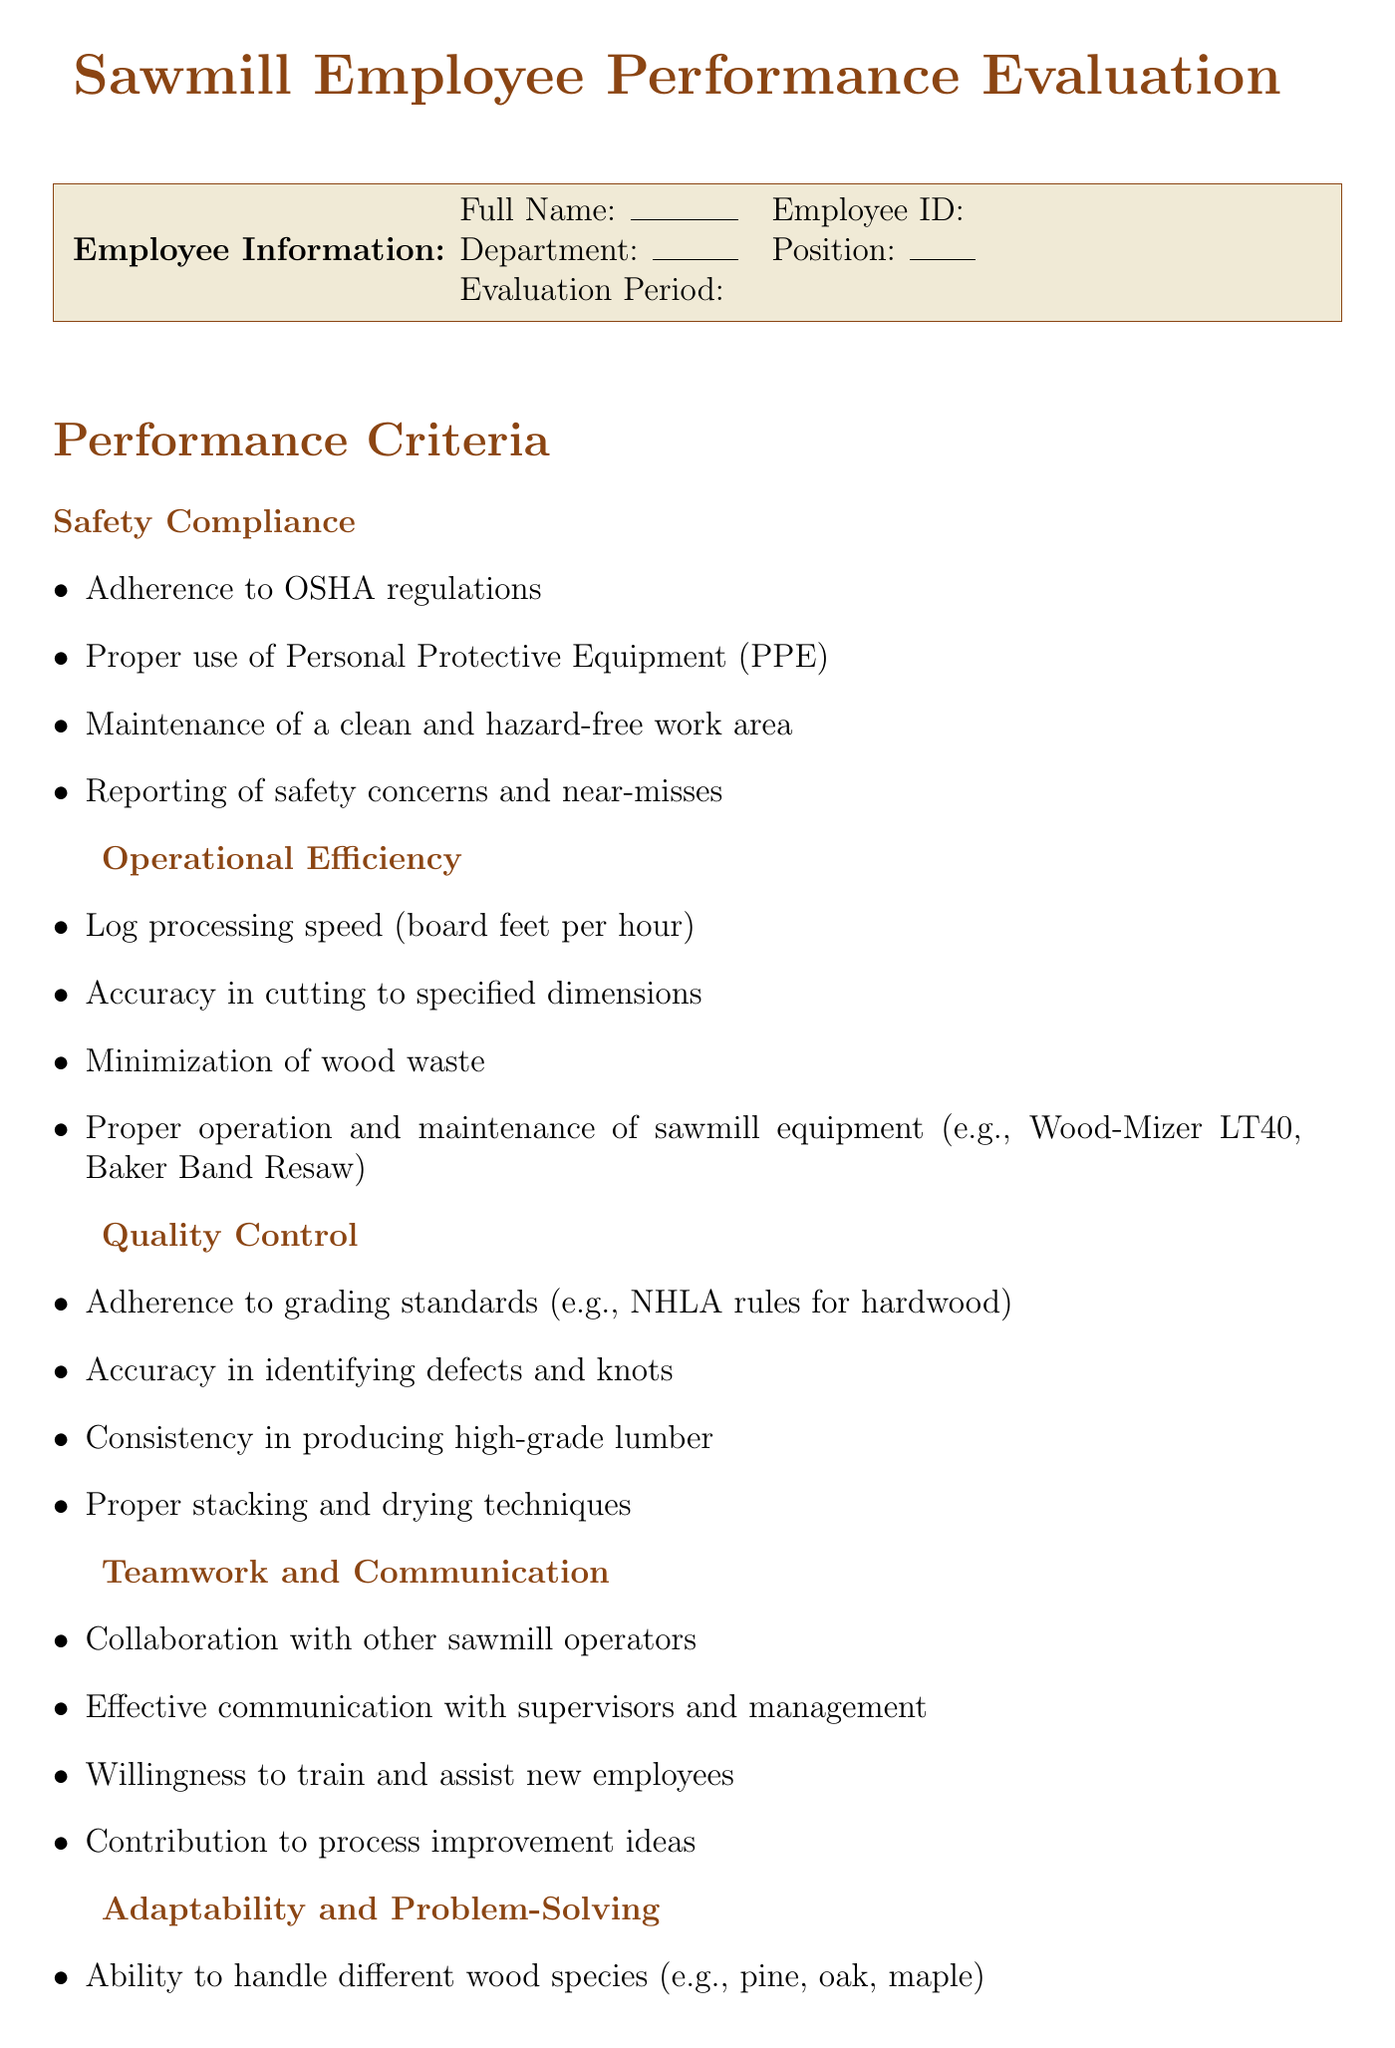What is the title of the form? The title of the form is prominently displayed at the top of the document, indicating its purpose.
Answer: Sawmill Employee Performance Evaluation How many categories are in the performance criteria? The performance criteria section lists five distinct categories of evaluation.
Answer: 5 What is the score description for a score of 3? The rating scale provides detailed descriptions for each score, including what it means to meet expectations.
Answer: Meets Expectations - Consistently meets job requirements What should be included in the development plan? The development plan section specifies three components that need to be filled out for future improvements.
Answer: Areas for Improvement, Training Recommendations, Goals for Next Evaluation Period What is the employee signature section for? This section is designated for the employee to acknowledge the evaluation and provide their signature and date.
Answer: Employee Signature and Date Which equipment is mentioned in the operational efficiency criteria? The operational efficiency criteria specifically reference two pieces of sawmill equipment as part of the evaluation.
Answer: Wood-Mizer LT40, Baker Band Resaw What is the purpose of the overall performance section? This section summarizes the employee's performance evaluation scores and provides a performance summary.
Answer: Total Score, Average Score, Performance Summary What is one subcriterion under Teamwork and Communication? Each category lists subcriteria that provide specific areas for evaluation; one of these pertains to teamwork.
Answer: Collaboration with other sawmill operators 